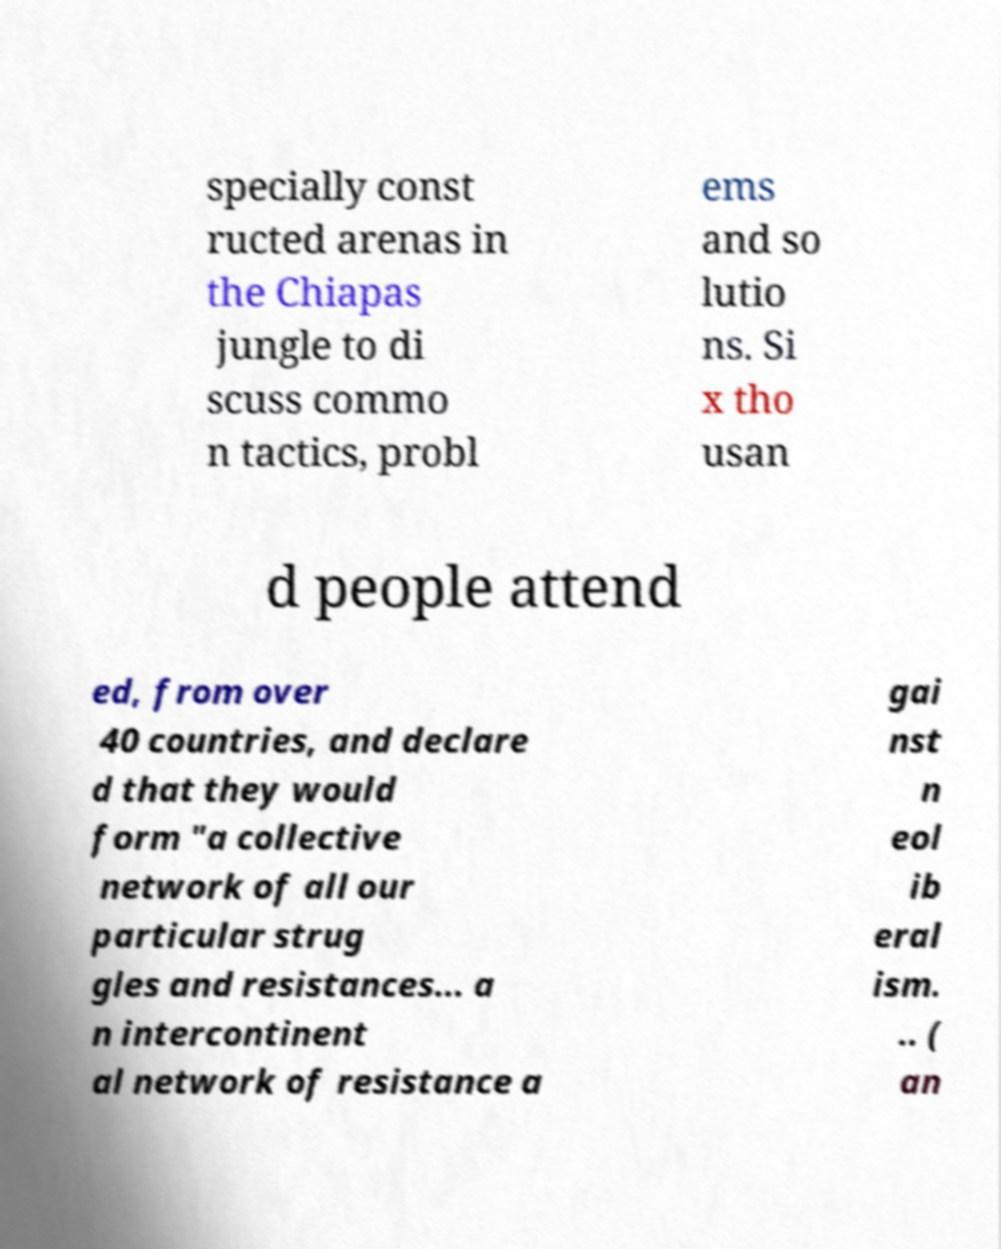For documentation purposes, I need the text within this image transcribed. Could you provide that? specially const ructed arenas in the Chiapas jungle to di scuss commo n tactics, probl ems and so lutio ns. Si x tho usan d people attend ed, from over 40 countries, and declare d that they would form "a collective network of all our particular strug gles and resistances... a n intercontinent al network of resistance a gai nst n eol ib eral ism. .. ( an 